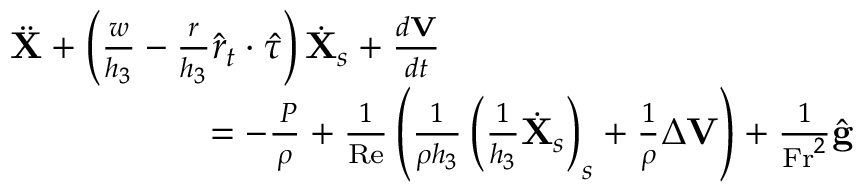<formula> <loc_0><loc_0><loc_500><loc_500>\begin{array} { r } { \ddot { X } + \left ( \frac { w } { h _ { 3 } } - \frac { r } { h _ { 3 } } \hat { r } _ { t } \cdot \hat { \tau } \right ) \dot { X } _ { s } + \frac { d V } { d t } \quad } \\ { = - \frac { \nabla P } { \rho } + \frac { 1 } { R e } \left ( \frac { 1 } { \rho h _ { 3 } } \left ( \frac { 1 } { h _ { 3 } } \dot { X } _ { s } \right ) _ { s } + \frac { 1 } { \rho } \Delta V \right ) + \frac { 1 } { F r ^ { 2 } } \hat { g } } \end{array}</formula> 